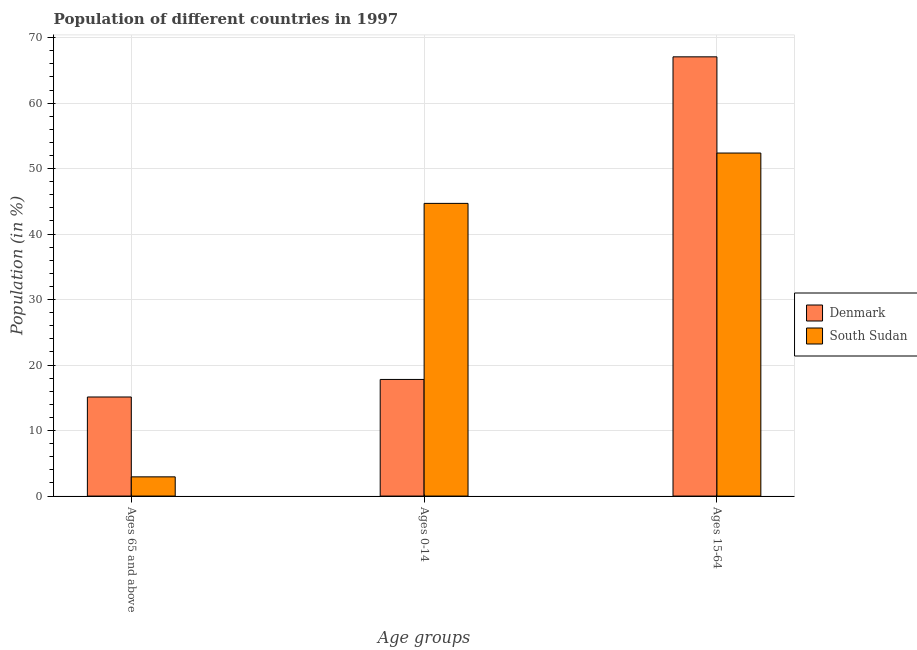How many different coloured bars are there?
Keep it short and to the point. 2. Are the number of bars per tick equal to the number of legend labels?
Your answer should be very brief. Yes. What is the label of the 1st group of bars from the left?
Your answer should be very brief. Ages 65 and above. What is the percentage of population within the age-group 15-64 in South Sudan?
Offer a terse response. 52.38. Across all countries, what is the maximum percentage of population within the age-group of 65 and above?
Provide a succinct answer. 15.13. Across all countries, what is the minimum percentage of population within the age-group 0-14?
Provide a succinct answer. 17.81. In which country was the percentage of population within the age-group 15-64 maximum?
Your answer should be compact. Denmark. In which country was the percentage of population within the age-group of 65 and above minimum?
Give a very brief answer. South Sudan. What is the total percentage of population within the age-group of 65 and above in the graph?
Give a very brief answer. 18.06. What is the difference between the percentage of population within the age-group 15-64 in Denmark and that in South Sudan?
Give a very brief answer. 14.69. What is the difference between the percentage of population within the age-group 15-64 in South Sudan and the percentage of population within the age-group 0-14 in Denmark?
Offer a terse response. 34.57. What is the average percentage of population within the age-group 15-64 per country?
Offer a very short reply. 59.72. What is the difference between the percentage of population within the age-group 15-64 and percentage of population within the age-group 0-14 in South Sudan?
Your answer should be compact. 7.69. What is the ratio of the percentage of population within the age-group 15-64 in Denmark to that in South Sudan?
Ensure brevity in your answer.  1.28. Is the difference between the percentage of population within the age-group 15-64 in South Sudan and Denmark greater than the difference between the percentage of population within the age-group of 65 and above in South Sudan and Denmark?
Provide a succinct answer. No. What is the difference between the highest and the second highest percentage of population within the age-group of 65 and above?
Keep it short and to the point. 12.19. What is the difference between the highest and the lowest percentage of population within the age-group 15-64?
Ensure brevity in your answer.  14.69. In how many countries, is the percentage of population within the age-group 0-14 greater than the average percentage of population within the age-group 0-14 taken over all countries?
Your response must be concise. 1. What does the 1st bar from the right in Ages 15-64 represents?
Provide a short and direct response. South Sudan. How many bars are there?
Provide a succinct answer. 6. Are all the bars in the graph horizontal?
Your response must be concise. No. How many countries are there in the graph?
Give a very brief answer. 2. Are the values on the major ticks of Y-axis written in scientific E-notation?
Provide a short and direct response. No. Does the graph contain any zero values?
Offer a terse response. No. Where does the legend appear in the graph?
Your response must be concise. Center right. How are the legend labels stacked?
Your answer should be very brief. Vertical. What is the title of the graph?
Make the answer very short. Population of different countries in 1997. Does "Malaysia" appear as one of the legend labels in the graph?
Provide a succinct answer. No. What is the label or title of the X-axis?
Make the answer very short. Age groups. What is the label or title of the Y-axis?
Offer a very short reply. Population (in %). What is the Population (in %) of Denmark in Ages 65 and above?
Offer a terse response. 15.13. What is the Population (in %) of South Sudan in Ages 65 and above?
Offer a very short reply. 2.93. What is the Population (in %) of Denmark in Ages 0-14?
Make the answer very short. 17.81. What is the Population (in %) in South Sudan in Ages 0-14?
Ensure brevity in your answer.  44.69. What is the Population (in %) in Denmark in Ages 15-64?
Ensure brevity in your answer.  67.06. What is the Population (in %) of South Sudan in Ages 15-64?
Make the answer very short. 52.38. Across all Age groups, what is the maximum Population (in %) of Denmark?
Offer a very short reply. 67.06. Across all Age groups, what is the maximum Population (in %) of South Sudan?
Provide a succinct answer. 52.38. Across all Age groups, what is the minimum Population (in %) of Denmark?
Offer a terse response. 15.13. Across all Age groups, what is the minimum Population (in %) in South Sudan?
Make the answer very short. 2.93. What is the difference between the Population (in %) of Denmark in Ages 65 and above and that in Ages 0-14?
Ensure brevity in your answer.  -2.68. What is the difference between the Population (in %) of South Sudan in Ages 65 and above and that in Ages 0-14?
Make the answer very short. -41.75. What is the difference between the Population (in %) in Denmark in Ages 65 and above and that in Ages 15-64?
Provide a short and direct response. -51.94. What is the difference between the Population (in %) of South Sudan in Ages 65 and above and that in Ages 15-64?
Offer a very short reply. -49.44. What is the difference between the Population (in %) of Denmark in Ages 0-14 and that in Ages 15-64?
Provide a succinct answer. -49.26. What is the difference between the Population (in %) in South Sudan in Ages 0-14 and that in Ages 15-64?
Give a very brief answer. -7.69. What is the difference between the Population (in %) of Denmark in Ages 65 and above and the Population (in %) of South Sudan in Ages 0-14?
Give a very brief answer. -29.56. What is the difference between the Population (in %) in Denmark in Ages 65 and above and the Population (in %) in South Sudan in Ages 15-64?
Provide a short and direct response. -37.25. What is the difference between the Population (in %) of Denmark in Ages 0-14 and the Population (in %) of South Sudan in Ages 15-64?
Keep it short and to the point. -34.57. What is the average Population (in %) of Denmark per Age groups?
Provide a short and direct response. 33.33. What is the average Population (in %) in South Sudan per Age groups?
Keep it short and to the point. 33.33. What is the difference between the Population (in %) of Denmark and Population (in %) of South Sudan in Ages 65 and above?
Ensure brevity in your answer.  12.19. What is the difference between the Population (in %) in Denmark and Population (in %) in South Sudan in Ages 0-14?
Give a very brief answer. -26.88. What is the difference between the Population (in %) in Denmark and Population (in %) in South Sudan in Ages 15-64?
Your answer should be very brief. 14.69. What is the ratio of the Population (in %) in Denmark in Ages 65 and above to that in Ages 0-14?
Ensure brevity in your answer.  0.85. What is the ratio of the Population (in %) in South Sudan in Ages 65 and above to that in Ages 0-14?
Your answer should be very brief. 0.07. What is the ratio of the Population (in %) in Denmark in Ages 65 and above to that in Ages 15-64?
Keep it short and to the point. 0.23. What is the ratio of the Population (in %) of South Sudan in Ages 65 and above to that in Ages 15-64?
Provide a short and direct response. 0.06. What is the ratio of the Population (in %) of Denmark in Ages 0-14 to that in Ages 15-64?
Give a very brief answer. 0.27. What is the ratio of the Population (in %) in South Sudan in Ages 0-14 to that in Ages 15-64?
Offer a terse response. 0.85. What is the difference between the highest and the second highest Population (in %) in Denmark?
Ensure brevity in your answer.  49.26. What is the difference between the highest and the second highest Population (in %) of South Sudan?
Your response must be concise. 7.69. What is the difference between the highest and the lowest Population (in %) in Denmark?
Your answer should be very brief. 51.94. What is the difference between the highest and the lowest Population (in %) in South Sudan?
Offer a very short reply. 49.44. 